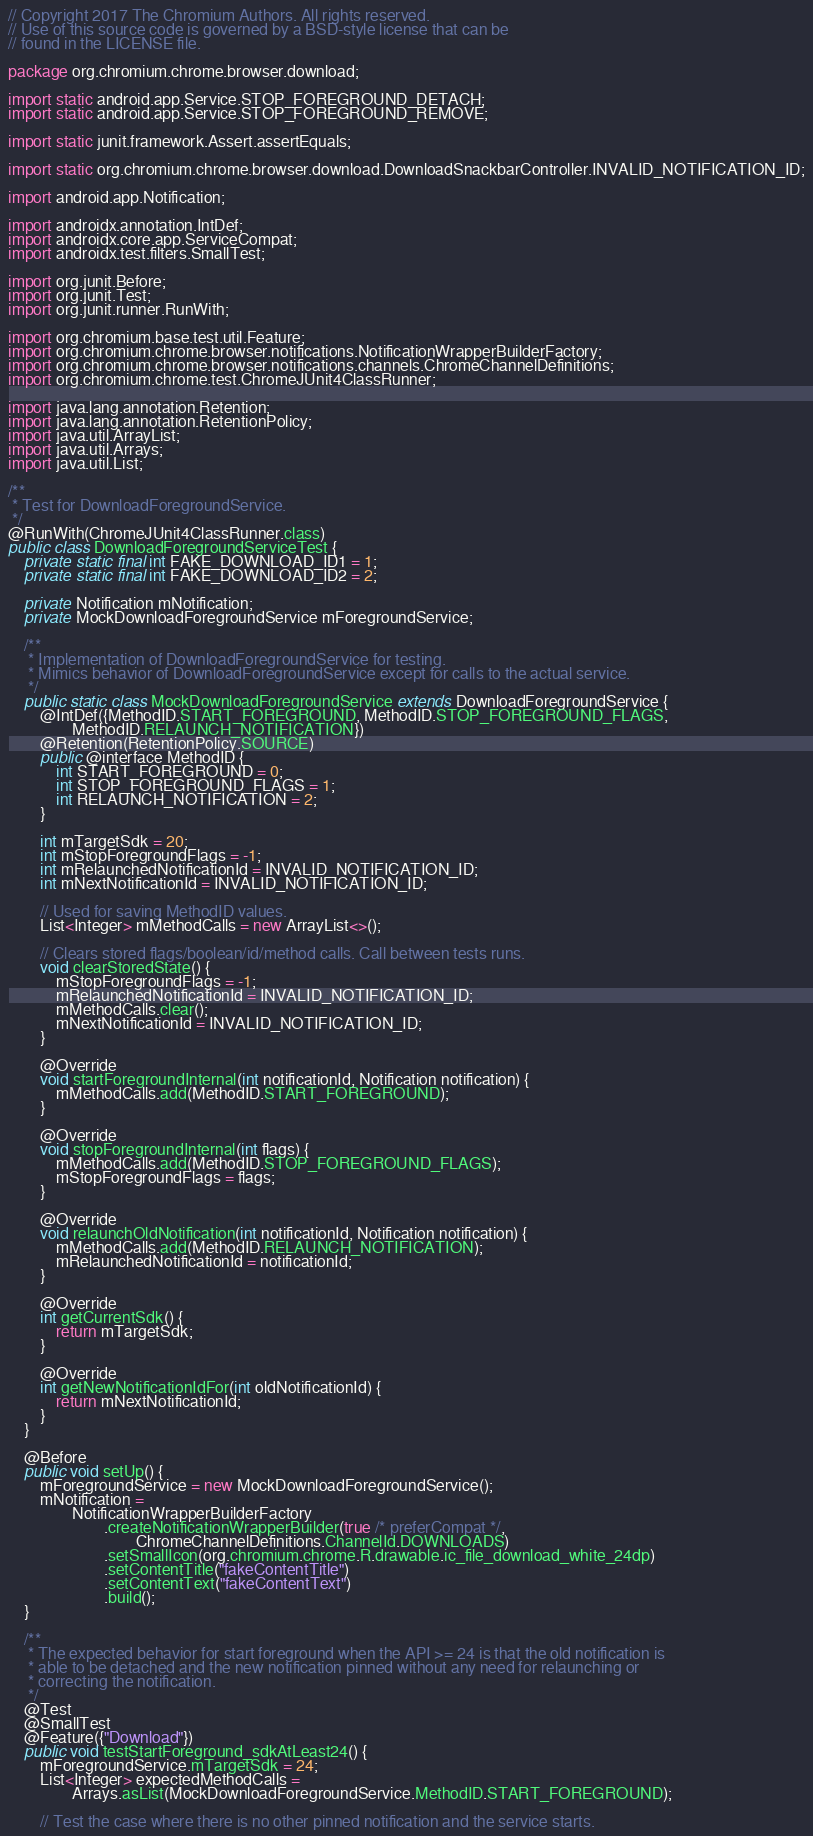Convert code to text. <code><loc_0><loc_0><loc_500><loc_500><_Java_>// Copyright 2017 The Chromium Authors. All rights reserved.
// Use of this source code is governed by a BSD-style license that can be
// found in the LICENSE file.

package org.chromium.chrome.browser.download;

import static android.app.Service.STOP_FOREGROUND_DETACH;
import static android.app.Service.STOP_FOREGROUND_REMOVE;

import static junit.framework.Assert.assertEquals;

import static org.chromium.chrome.browser.download.DownloadSnackbarController.INVALID_NOTIFICATION_ID;

import android.app.Notification;

import androidx.annotation.IntDef;
import androidx.core.app.ServiceCompat;
import androidx.test.filters.SmallTest;

import org.junit.Before;
import org.junit.Test;
import org.junit.runner.RunWith;

import org.chromium.base.test.util.Feature;
import org.chromium.chrome.browser.notifications.NotificationWrapperBuilderFactory;
import org.chromium.chrome.browser.notifications.channels.ChromeChannelDefinitions;
import org.chromium.chrome.test.ChromeJUnit4ClassRunner;

import java.lang.annotation.Retention;
import java.lang.annotation.RetentionPolicy;
import java.util.ArrayList;
import java.util.Arrays;
import java.util.List;

/**
 * Test for DownloadForegroundService.
 */
@RunWith(ChromeJUnit4ClassRunner.class)
public class DownloadForegroundServiceTest {
    private static final int FAKE_DOWNLOAD_ID1 = 1;
    private static final int FAKE_DOWNLOAD_ID2 = 2;

    private Notification mNotification;
    private MockDownloadForegroundService mForegroundService;

    /**
     * Implementation of DownloadForegroundService for testing.
     * Mimics behavior of DownloadForegroundService except for calls to the actual service.
     */
    public static class MockDownloadForegroundService extends DownloadForegroundService {
        @IntDef({MethodID.START_FOREGROUND, MethodID.STOP_FOREGROUND_FLAGS,
                MethodID.RELAUNCH_NOTIFICATION})
        @Retention(RetentionPolicy.SOURCE)
        public @interface MethodID {
            int START_FOREGROUND = 0;
            int STOP_FOREGROUND_FLAGS = 1;
            int RELAUNCH_NOTIFICATION = 2;
        }

        int mTargetSdk = 20;
        int mStopForegroundFlags = -1;
        int mRelaunchedNotificationId = INVALID_NOTIFICATION_ID;
        int mNextNotificationId = INVALID_NOTIFICATION_ID;

        // Used for saving MethodID values.
        List<Integer> mMethodCalls = new ArrayList<>();

        // Clears stored flags/boolean/id/method calls. Call between tests runs.
        void clearStoredState() {
            mStopForegroundFlags = -1;
            mRelaunchedNotificationId = INVALID_NOTIFICATION_ID;
            mMethodCalls.clear();
            mNextNotificationId = INVALID_NOTIFICATION_ID;
        }

        @Override
        void startForegroundInternal(int notificationId, Notification notification) {
            mMethodCalls.add(MethodID.START_FOREGROUND);
        }

        @Override
        void stopForegroundInternal(int flags) {
            mMethodCalls.add(MethodID.STOP_FOREGROUND_FLAGS);
            mStopForegroundFlags = flags;
        }

        @Override
        void relaunchOldNotification(int notificationId, Notification notification) {
            mMethodCalls.add(MethodID.RELAUNCH_NOTIFICATION);
            mRelaunchedNotificationId = notificationId;
        }

        @Override
        int getCurrentSdk() {
            return mTargetSdk;
        }

        @Override
        int getNewNotificationIdFor(int oldNotificationId) {
            return mNextNotificationId;
        }
    }

    @Before
    public void setUp() {
        mForegroundService = new MockDownloadForegroundService();
        mNotification =
                NotificationWrapperBuilderFactory
                        .createNotificationWrapperBuilder(true /* preferCompat */,
                                ChromeChannelDefinitions.ChannelId.DOWNLOADS)
                        .setSmallIcon(org.chromium.chrome.R.drawable.ic_file_download_white_24dp)
                        .setContentTitle("fakeContentTitle")
                        .setContentText("fakeContentText")
                        .build();
    }

    /**
     * The expected behavior for start foreground when the API >= 24 is that the old notification is
     * able to be detached and the new notification pinned without any need for relaunching or
     * correcting the notification.
     */
    @Test
    @SmallTest
    @Feature({"Download"})
    public void testStartForeground_sdkAtLeast24() {
        mForegroundService.mTargetSdk = 24;
        List<Integer> expectedMethodCalls =
                Arrays.asList(MockDownloadForegroundService.MethodID.START_FOREGROUND);

        // Test the case where there is no other pinned notification and the service starts.</code> 